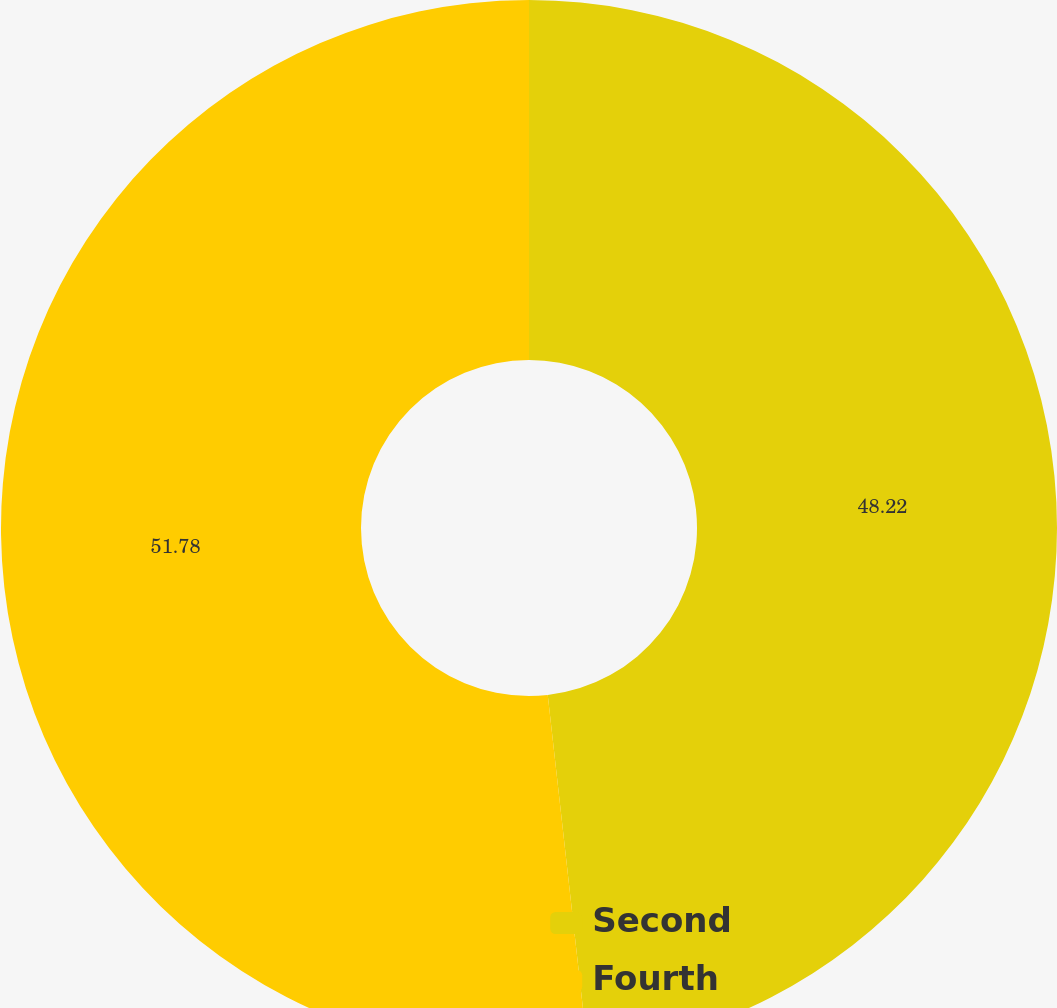Convert chart to OTSL. <chart><loc_0><loc_0><loc_500><loc_500><pie_chart><fcel>Second<fcel>Fourth<nl><fcel>48.22%<fcel>51.78%<nl></chart> 